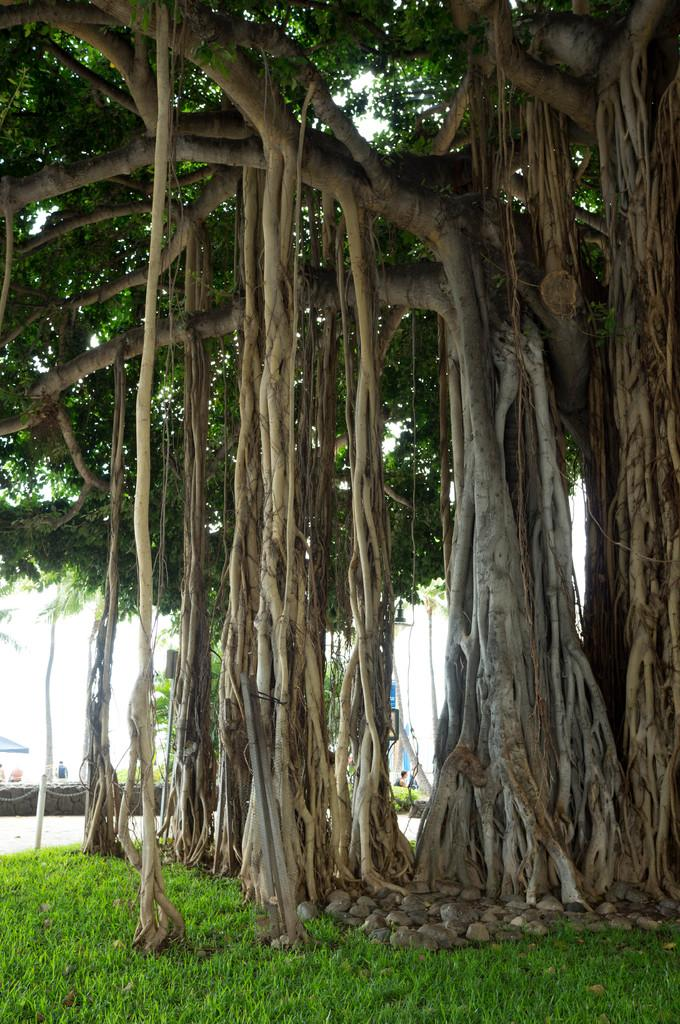What can be seen in the foreground of the picture? In the foreground of the picture, there are rocks, grass, and a tree. What is visible in the background towards the left? In the background towards the left, there are plants, people, and other objects. What part of the natural environment is visible in the picture? Sky is visible in the background of the picture. What type of scene is depicted in the image? The image does not depict a specific scene; it is a photograph of a natural environment with rocks, grass, a tree, plants, people, and other objects. Can you tell me how many flags are visible in the image? There are no flags present in the image. 